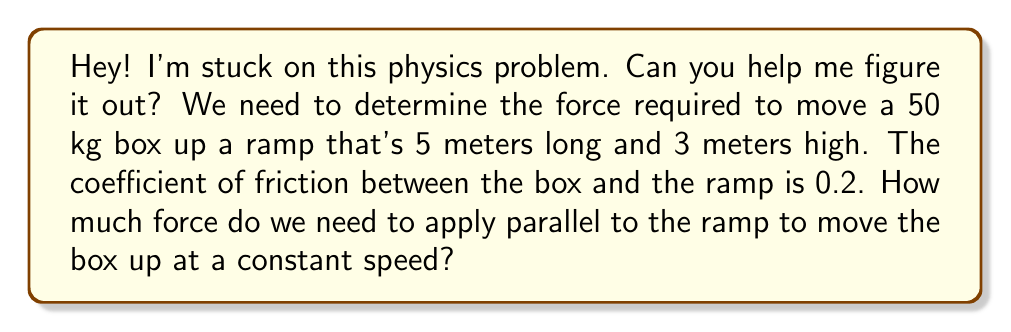Can you solve this math problem? Sure! Let's solve this problem step by step:

1. First, we need to find the angle of the incline:
   $$\sin \theta = \frac{\text{opposite}}{\text{hypotenuse}} = \frac{3}{5}$$
   $$\theta = \arcsin(\frac{3}{5}) \approx 36.87°$$

2. Now, let's identify the forces acting on the box:
   - Weight (W): $W = mg = 50 \times 9.8 = 490$ N (downward)
   - Normal force (N): perpendicular to the ramp
   - Friction force (f): $f = \mu N$, where $\mu = 0.2$
   - Applied force (F): parallel to the ramp (what we're solving for)

3. Resolve the weight into components parallel and perpendicular to the ramp:
   - Parallel: $W_{\parallel} = W \sin \theta = 490 \sin 36.87° \approx 294$ N
   - Perpendicular: $W_{\perp} = W \cos \theta = 490 \cos 36.87° \approx 392$ N

4. The normal force equals the perpendicular component of weight:
   $N = W_{\perp} \approx 392$ N

5. Calculate the friction force:
   $f = \mu N = 0.2 \times 392 \approx 78.4$ N

6. For constant speed, the sum of forces parallel to the ramp must be zero:
   $$F - W_{\parallel} - f = 0$$
   $$F = W_{\parallel} + f = 294 + 78.4 \approx 372.4$$

Therefore, the force required to move the box up the ramp at constant speed is approximately 372.4 N.
Answer: $372.4$ N 